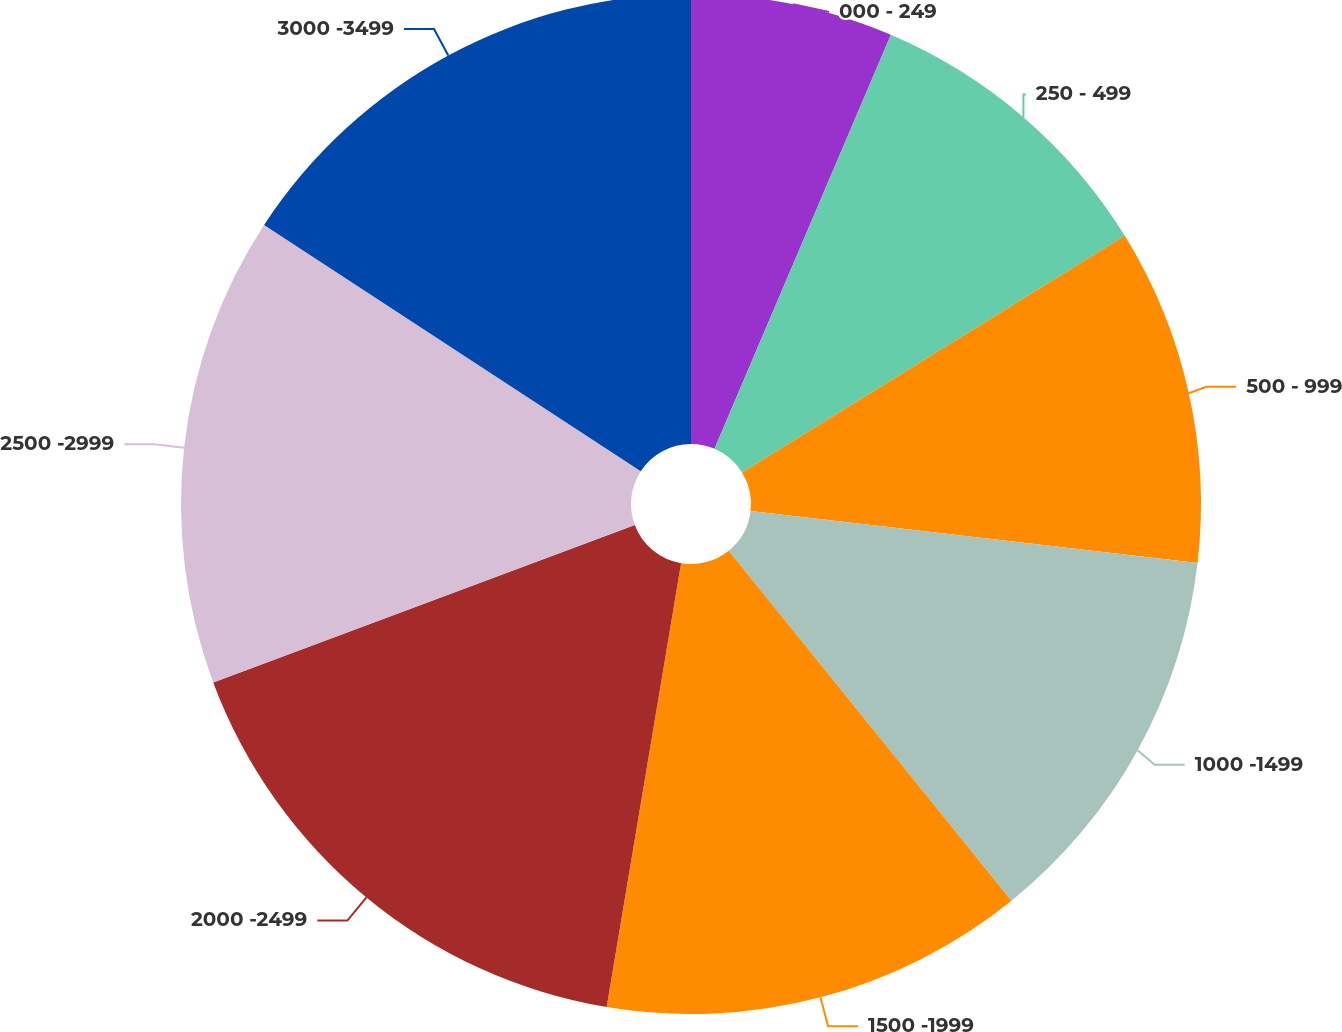Convert chart. <chart><loc_0><loc_0><loc_500><loc_500><pie_chart><fcel>000 - 249<fcel>250 - 499<fcel>500 - 999<fcel>1000 -1499<fcel>1500 -1999<fcel>2000 -2499<fcel>2500 -2999<fcel>3000 -3499<nl><fcel>6.41%<fcel>9.78%<fcel>10.66%<fcel>12.34%<fcel>13.46%<fcel>16.67%<fcel>14.9%<fcel>15.79%<nl></chart> 